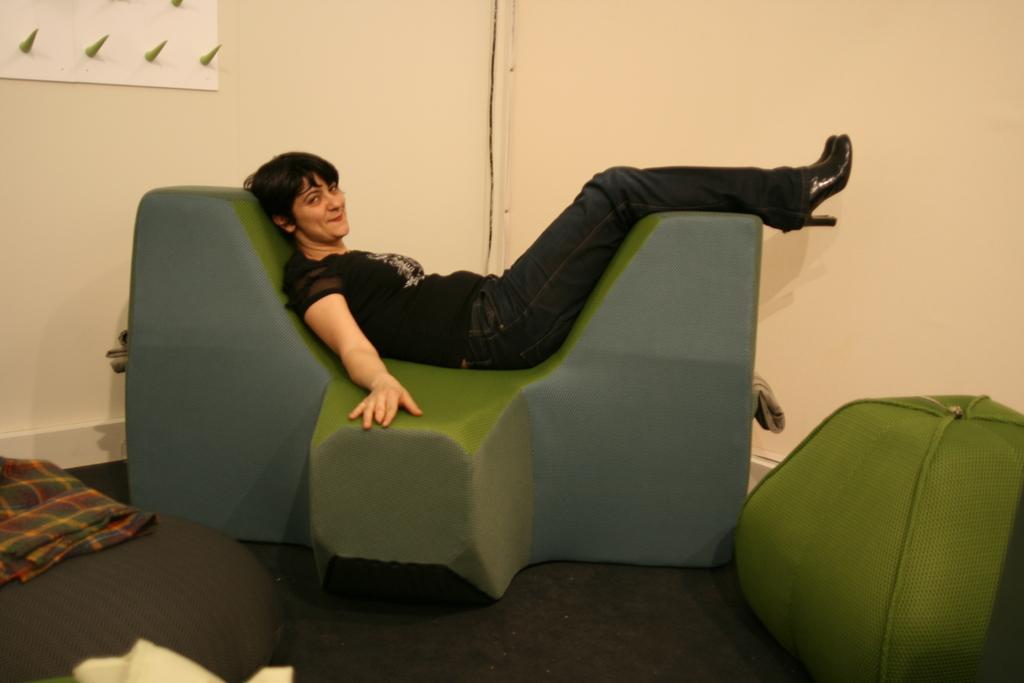Describe this image in one or two sentences. In this picture we can observe a woman laying on this sofa. The woman is wearing a black color dress and smiling. The sofa is in green and grey color. We can observe green color object on the right side. In the background there is a wall which is in cream color. 